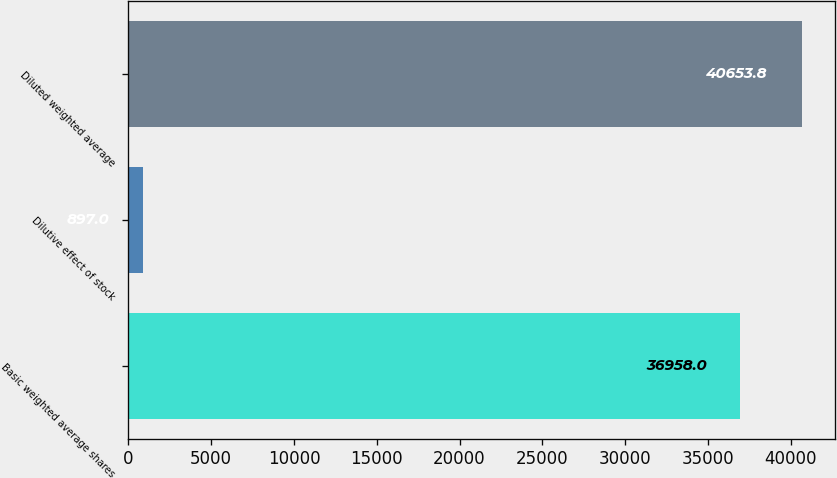Convert chart. <chart><loc_0><loc_0><loc_500><loc_500><bar_chart><fcel>Basic weighted average shares<fcel>Dilutive effect of stock<fcel>Diluted weighted average<nl><fcel>36958<fcel>897<fcel>40653.8<nl></chart> 